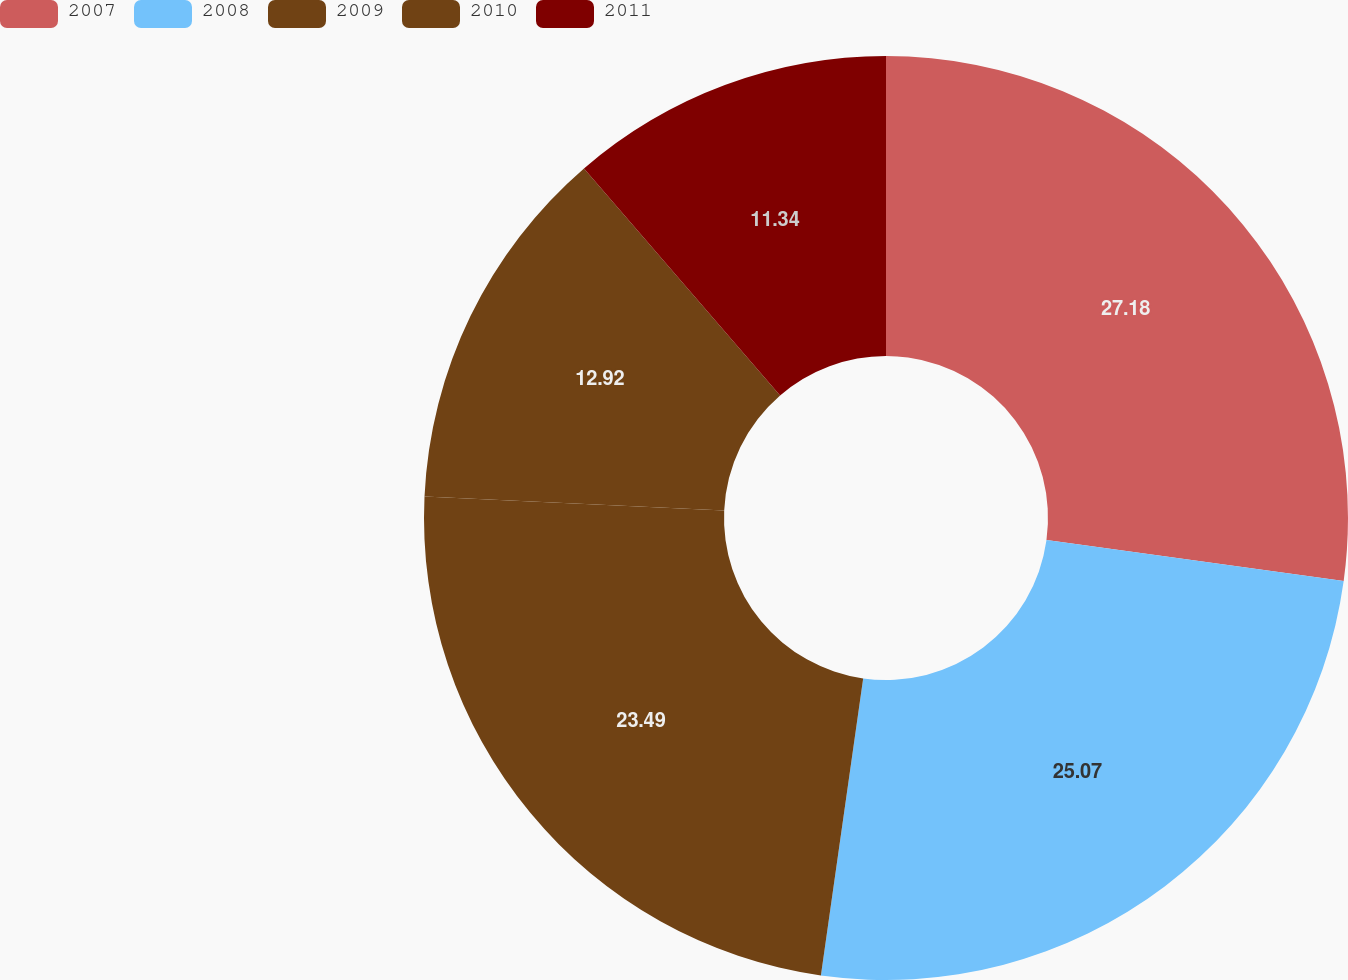Convert chart. <chart><loc_0><loc_0><loc_500><loc_500><pie_chart><fcel>2007<fcel>2008<fcel>2009<fcel>2010<fcel>2011<nl><fcel>27.18%<fcel>25.07%<fcel>23.49%<fcel>12.92%<fcel>11.34%<nl></chart> 